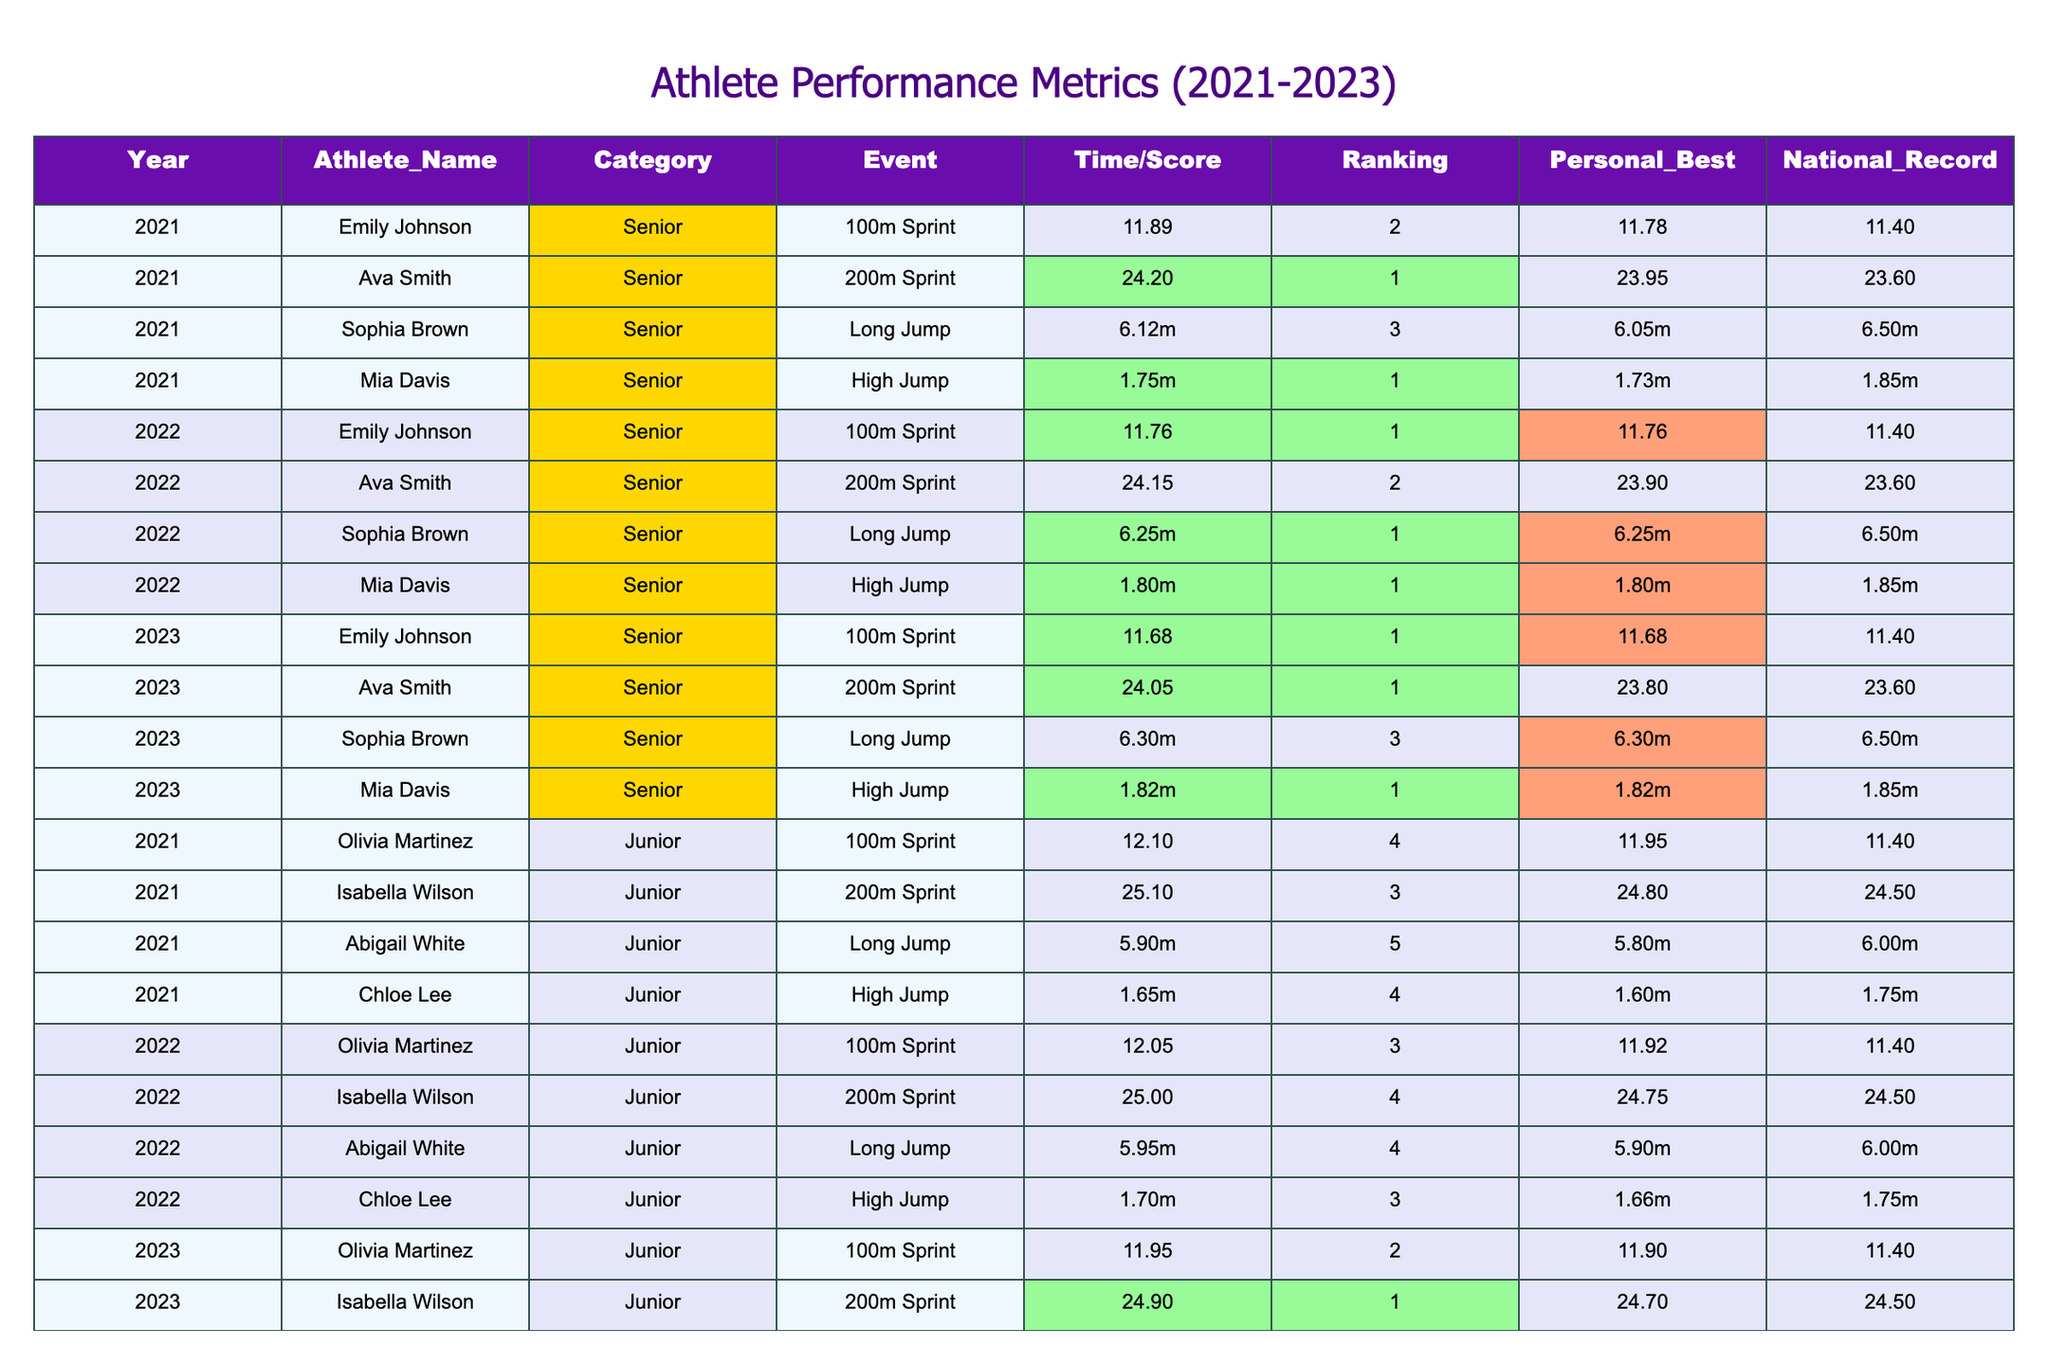What athlete had the best ranking in the 100m Sprint in 2022? In 2022, Emily Johnson had the best ranking in the 100m Sprint with a ranking of 1.
Answer: Emily Johnson What is Ava Smith's personal best in the 200m Sprint? Ava Smith's personal best time in the 200m Sprint is 23.90 seconds, as stated in her record for 2022.
Answer: 23.90 seconds Which athlete achieved a national record in the high jump? None of the athletes achieved a national record in the high jump, as the highest national record of 1.85m was not surpassed by any of them over the three years.
Answer: No What was the difference in the long jump distance achieved by Sophia Brown from 2022 to 2023? In 2022, Sophia Brown jumped 6.25m and in 2023, she jumped 6.30m. The difference is 6.30m - 6.25m = 0.05m.
Answer: 0.05m Which athlete improved their performance in the 100m Sprint each year from 2021 to 2023? Emily Johnson consistently improved her performance in the 100m Sprint, decreasing her times from 11.89 seconds in 2021 to 11.68 seconds in 2023.
Answer: Emily Johnson What is the average jump height achieved by Mia Davis in the high jump over the three years? Mia Davis achieved heights of 1.75m in 2021, 1.80m in 2022, and 1.82m in 2023. The average is (1.75m + 1.80m + 1.82m) / 3 = 1.79m.
Answer: 1.79m Did Ava Smith rank higher than Olivia Martinez in the 200m Sprint in 2023? Yes, Ava Smith ranked 1st in the 200m Sprint in 2023, while Olivia Martinez ranked 2nd.
Answer: Yes Who showed the most consistent improvement in long jump over the three years across all athletes? Sophia Brown showed consistent improvement, starting from 6.12m in 2021, to 6.25m in 2022, and reaching 6.30m in 2023.
Answer: Sophia Brown Which athlete had the highest personal best in the 200m Sprint and what was the value? Ava Smith had the highest personal best in the 200m Sprint at 23.80 seconds in 2023.
Answer: 23.80 seconds How many athletes ranked 1st in their events in 2023? Four athletes ranked 1st in their events in 2023: Emily Johnson (100m Sprint), Ava Smith (200m Sprint), Mia Davis (High Jump), and Isabella Wilson (200m Sprint).
Answer: Four athletes What is the total distance improved by Abigail White in the long jump from 2021 to 2023? Abigail White's long jump distances were 5.90m in 2021 and 5.80m in 2023, showing a decrease in distance of 5.90m - 5.80m = 0.10m.
Answer: -0.10m 